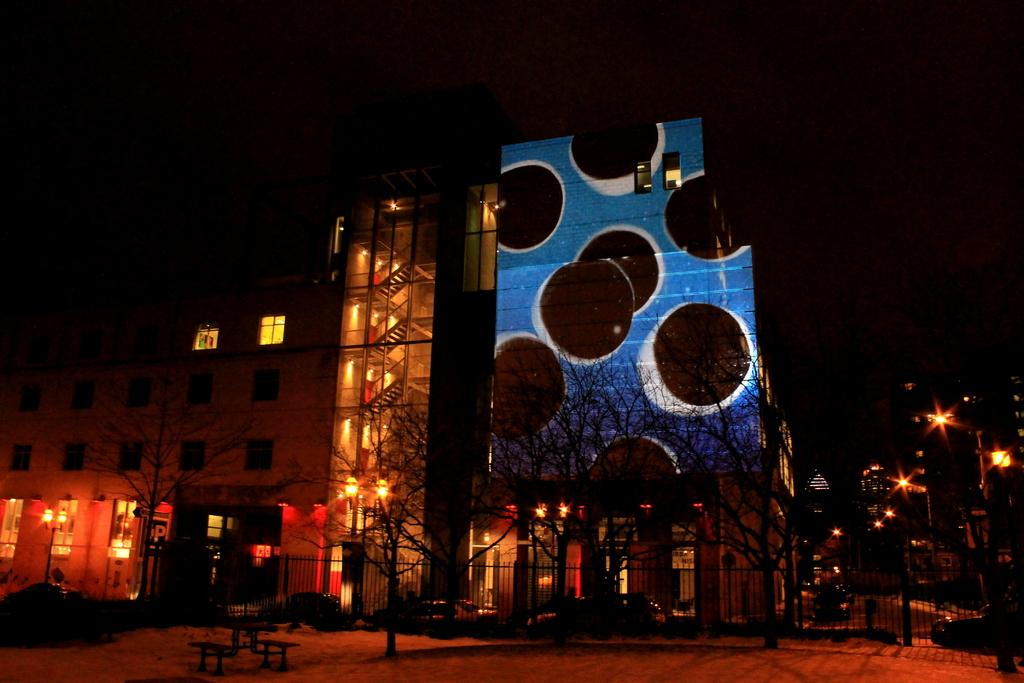What type of structures can be seen in the image? There are buildings in the image. What other objects are present in the image besides the buildings? There are poles and lights in the image. How would you describe the lighting conditions in the image? The background of the image is dark. What type of natural elements can be seen in the image? There are trees in the image. What type of silk fabric is draped over the oven in the image? There is no oven or silk fabric present in the image. How many balls are visible in the image? There are no balls visible in the image. 